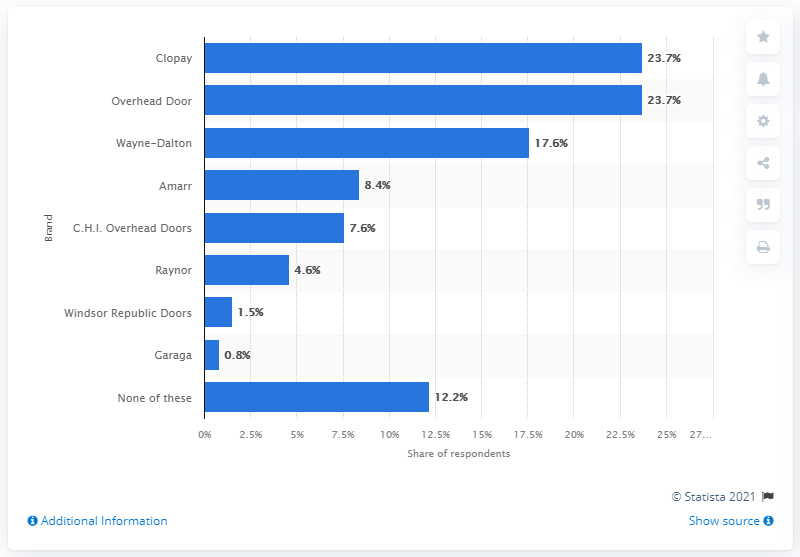What brand of garage doors did 17.6 percent of respondents use the most?
 Wayne-Dalton 